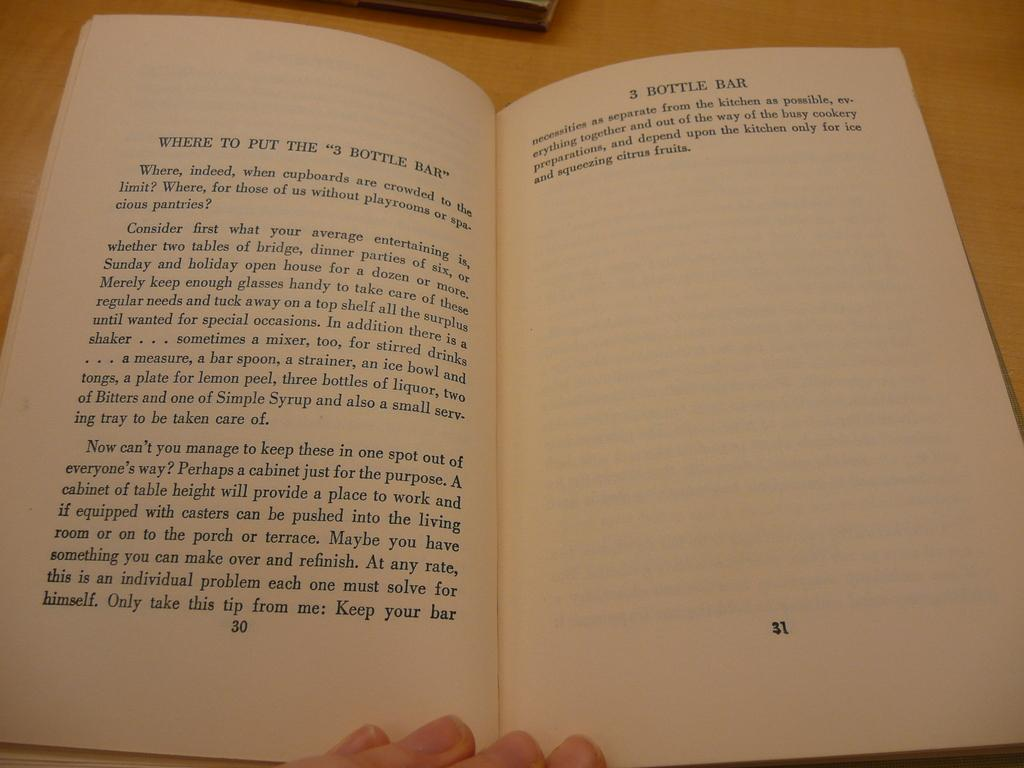Provide a one-sentence caption for the provided image. A book wondering where to put the 3 dollar bar. 